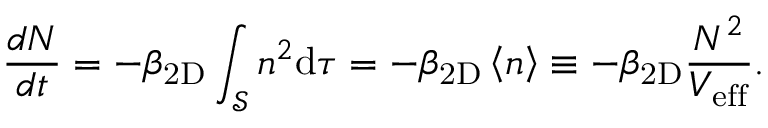<formula> <loc_0><loc_0><loc_500><loc_500>\frac { d N } { d t } = - \beta _ { 2 D } \int _ { \mathcal { S } } n ^ { 2 } d \tau = - \beta _ { 2 D } \left < n \right > \equiv - \beta _ { 2 D } \frac { N ^ { 2 } } { V _ { e f f } } .</formula> 